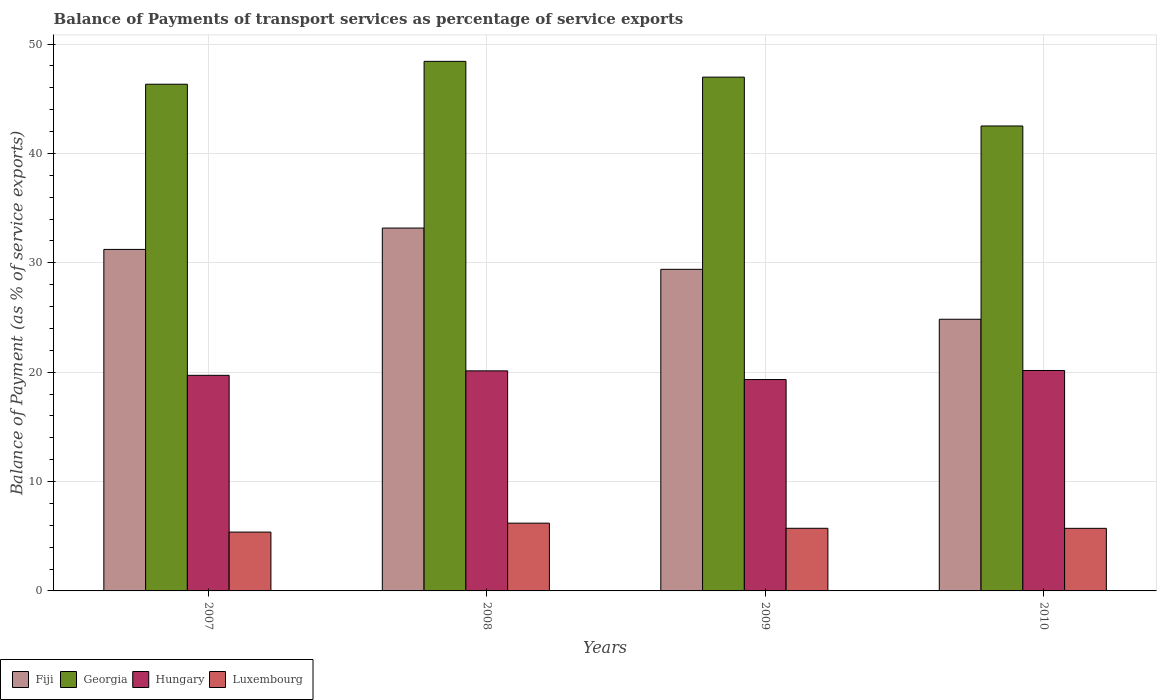Are the number of bars per tick equal to the number of legend labels?
Provide a succinct answer. Yes. Are the number of bars on each tick of the X-axis equal?
Ensure brevity in your answer.  Yes. How many bars are there on the 1st tick from the left?
Provide a succinct answer. 4. How many bars are there on the 4th tick from the right?
Give a very brief answer. 4. In how many cases, is the number of bars for a given year not equal to the number of legend labels?
Give a very brief answer. 0. What is the balance of payments of transport services in Hungary in 2009?
Your response must be concise. 19.33. Across all years, what is the maximum balance of payments of transport services in Luxembourg?
Provide a succinct answer. 6.2. Across all years, what is the minimum balance of payments of transport services in Hungary?
Ensure brevity in your answer.  19.33. What is the total balance of payments of transport services in Georgia in the graph?
Your answer should be compact. 184.22. What is the difference between the balance of payments of transport services in Luxembourg in 2007 and that in 2010?
Ensure brevity in your answer.  -0.34. What is the difference between the balance of payments of transport services in Fiji in 2008 and the balance of payments of transport services in Hungary in 2009?
Provide a succinct answer. 13.85. What is the average balance of payments of transport services in Fiji per year?
Provide a short and direct response. 29.66. In the year 2010, what is the difference between the balance of payments of transport services in Hungary and balance of payments of transport services in Luxembourg?
Make the answer very short. 14.43. What is the ratio of the balance of payments of transport services in Fiji in 2008 to that in 2010?
Offer a terse response. 1.34. What is the difference between the highest and the second highest balance of payments of transport services in Fiji?
Your answer should be very brief. 1.95. What is the difference between the highest and the lowest balance of payments of transport services in Hungary?
Offer a very short reply. 0.83. Is it the case that in every year, the sum of the balance of payments of transport services in Luxembourg and balance of payments of transport services in Fiji is greater than the sum of balance of payments of transport services in Georgia and balance of payments of transport services in Hungary?
Your answer should be compact. Yes. What does the 4th bar from the left in 2008 represents?
Give a very brief answer. Luxembourg. What does the 3rd bar from the right in 2010 represents?
Offer a very short reply. Georgia. Is it the case that in every year, the sum of the balance of payments of transport services in Fiji and balance of payments of transport services in Luxembourg is greater than the balance of payments of transport services in Georgia?
Keep it short and to the point. No. How many bars are there?
Your answer should be compact. 16. What is the difference between two consecutive major ticks on the Y-axis?
Your response must be concise. 10. Are the values on the major ticks of Y-axis written in scientific E-notation?
Make the answer very short. No. Does the graph contain any zero values?
Ensure brevity in your answer.  No. Does the graph contain grids?
Offer a very short reply. Yes. What is the title of the graph?
Give a very brief answer. Balance of Payments of transport services as percentage of service exports. What is the label or title of the X-axis?
Provide a succinct answer. Years. What is the label or title of the Y-axis?
Provide a short and direct response. Balance of Payment (as % of service exports). What is the Balance of Payment (as % of service exports) of Fiji in 2007?
Your answer should be very brief. 31.22. What is the Balance of Payment (as % of service exports) in Georgia in 2007?
Your response must be concise. 46.33. What is the Balance of Payment (as % of service exports) in Hungary in 2007?
Your response must be concise. 19.71. What is the Balance of Payment (as % of service exports) in Luxembourg in 2007?
Your response must be concise. 5.38. What is the Balance of Payment (as % of service exports) of Fiji in 2008?
Your answer should be compact. 33.18. What is the Balance of Payment (as % of service exports) in Georgia in 2008?
Your answer should be compact. 48.42. What is the Balance of Payment (as % of service exports) in Hungary in 2008?
Provide a short and direct response. 20.12. What is the Balance of Payment (as % of service exports) in Luxembourg in 2008?
Your answer should be very brief. 6.2. What is the Balance of Payment (as % of service exports) of Fiji in 2009?
Keep it short and to the point. 29.4. What is the Balance of Payment (as % of service exports) of Georgia in 2009?
Ensure brevity in your answer.  46.97. What is the Balance of Payment (as % of service exports) in Hungary in 2009?
Your answer should be very brief. 19.33. What is the Balance of Payment (as % of service exports) in Luxembourg in 2009?
Provide a short and direct response. 5.73. What is the Balance of Payment (as % of service exports) of Fiji in 2010?
Offer a terse response. 24.84. What is the Balance of Payment (as % of service exports) in Georgia in 2010?
Your answer should be compact. 42.51. What is the Balance of Payment (as % of service exports) of Hungary in 2010?
Make the answer very short. 20.15. What is the Balance of Payment (as % of service exports) of Luxembourg in 2010?
Provide a succinct answer. 5.72. Across all years, what is the maximum Balance of Payment (as % of service exports) of Fiji?
Offer a terse response. 33.18. Across all years, what is the maximum Balance of Payment (as % of service exports) in Georgia?
Provide a short and direct response. 48.42. Across all years, what is the maximum Balance of Payment (as % of service exports) of Hungary?
Offer a very short reply. 20.15. Across all years, what is the maximum Balance of Payment (as % of service exports) of Luxembourg?
Keep it short and to the point. 6.2. Across all years, what is the minimum Balance of Payment (as % of service exports) in Fiji?
Offer a terse response. 24.84. Across all years, what is the minimum Balance of Payment (as % of service exports) of Georgia?
Keep it short and to the point. 42.51. Across all years, what is the minimum Balance of Payment (as % of service exports) of Hungary?
Offer a very short reply. 19.33. Across all years, what is the minimum Balance of Payment (as % of service exports) of Luxembourg?
Provide a succinct answer. 5.38. What is the total Balance of Payment (as % of service exports) in Fiji in the graph?
Offer a terse response. 118.64. What is the total Balance of Payment (as % of service exports) in Georgia in the graph?
Keep it short and to the point. 184.22. What is the total Balance of Payment (as % of service exports) in Hungary in the graph?
Give a very brief answer. 79.31. What is the total Balance of Payment (as % of service exports) of Luxembourg in the graph?
Make the answer very short. 23.02. What is the difference between the Balance of Payment (as % of service exports) in Fiji in 2007 and that in 2008?
Ensure brevity in your answer.  -1.95. What is the difference between the Balance of Payment (as % of service exports) in Georgia in 2007 and that in 2008?
Provide a short and direct response. -2.09. What is the difference between the Balance of Payment (as % of service exports) of Hungary in 2007 and that in 2008?
Offer a terse response. -0.41. What is the difference between the Balance of Payment (as % of service exports) of Luxembourg in 2007 and that in 2008?
Your answer should be compact. -0.82. What is the difference between the Balance of Payment (as % of service exports) of Fiji in 2007 and that in 2009?
Keep it short and to the point. 1.82. What is the difference between the Balance of Payment (as % of service exports) of Georgia in 2007 and that in 2009?
Ensure brevity in your answer.  -0.65. What is the difference between the Balance of Payment (as % of service exports) in Hungary in 2007 and that in 2009?
Your response must be concise. 0.39. What is the difference between the Balance of Payment (as % of service exports) in Luxembourg in 2007 and that in 2009?
Ensure brevity in your answer.  -0.35. What is the difference between the Balance of Payment (as % of service exports) of Fiji in 2007 and that in 2010?
Your answer should be compact. 6.39. What is the difference between the Balance of Payment (as % of service exports) in Georgia in 2007 and that in 2010?
Offer a very short reply. 3.82. What is the difference between the Balance of Payment (as % of service exports) in Hungary in 2007 and that in 2010?
Keep it short and to the point. -0.44. What is the difference between the Balance of Payment (as % of service exports) in Luxembourg in 2007 and that in 2010?
Your response must be concise. -0.34. What is the difference between the Balance of Payment (as % of service exports) of Fiji in 2008 and that in 2009?
Provide a short and direct response. 3.77. What is the difference between the Balance of Payment (as % of service exports) of Georgia in 2008 and that in 2009?
Keep it short and to the point. 1.44. What is the difference between the Balance of Payment (as % of service exports) of Hungary in 2008 and that in 2009?
Ensure brevity in your answer.  0.79. What is the difference between the Balance of Payment (as % of service exports) in Luxembourg in 2008 and that in 2009?
Give a very brief answer. 0.47. What is the difference between the Balance of Payment (as % of service exports) in Fiji in 2008 and that in 2010?
Keep it short and to the point. 8.34. What is the difference between the Balance of Payment (as % of service exports) of Georgia in 2008 and that in 2010?
Provide a succinct answer. 5.91. What is the difference between the Balance of Payment (as % of service exports) in Hungary in 2008 and that in 2010?
Offer a very short reply. -0.03. What is the difference between the Balance of Payment (as % of service exports) in Luxembourg in 2008 and that in 2010?
Offer a very short reply. 0.47. What is the difference between the Balance of Payment (as % of service exports) in Fiji in 2009 and that in 2010?
Give a very brief answer. 4.57. What is the difference between the Balance of Payment (as % of service exports) of Georgia in 2009 and that in 2010?
Your answer should be very brief. 4.47. What is the difference between the Balance of Payment (as % of service exports) in Hungary in 2009 and that in 2010?
Your answer should be very brief. -0.83. What is the difference between the Balance of Payment (as % of service exports) in Luxembourg in 2009 and that in 2010?
Your response must be concise. 0. What is the difference between the Balance of Payment (as % of service exports) of Fiji in 2007 and the Balance of Payment (as % of service exports) of Georgia in 2008?
Provide a succinct answer. -17.19. What is the difference between the Balance of Payment (as % of service exports) in Fiji in 2007 and the Balance of Payment (as % of service exports) in Hungary in 2008?
Your answer should be compact. 11.1. What is the difference between the Balance of Payment (as % of service exports) in Fiji in 2007 and the Balance of Payment (as % of service exports) in Luxembourg in 2008?
Ensure brevity in your answer.  25.03. What is the difference between the Balance of Payment (as % of service exports) in Georgia in 2007 and the Balance of Payment (as % of service exports) in Hungary in 2008?
Offer a very short reply. 26.21. What is the difference between the Balance of Payment (as % of service exports) of Georgia in 2007 and the Balance of Payment (as % of service exports) of Luxembourg in 2008?
Your response must be concise. 40.13. What is the difference between the Balance of Payment (as % of service exports) in Hungary in 2007 and the Balance of Payment (as % of service exports) in Luxembourg in 2008?
Provide a short and direct response. 13.52. What is the difference between the Balance of Payment (as % of service exports) of Fiji in 2007 and the Balance of Payment (as % of service exports) of Georgia in 2009?
Your answer should be compact. -15.75. What is the difference between the Balance of Payment (as % of service exports) in Fiji in 2007 and the Balance of Payment (as % of service exports) in Hungary in 2009?
Your answer should be compact. 11.9. What is the difference between the Balance of Payment (as % of service exports) in Fiji in 2007 and the Balance of Payment (as % of service exports) in Luxembourg in 2009?
Your response must be concise. 25.5. What is the difference between the Balance of Payment (as % of service exports) of Georgia in 2007 and the Balance of Payment (as % of service exports) of Hungary in 2009?
Your answer should be compact. 27. What is the difference between the Balance of Payment (as % of service exports) of Georgia in 2007 and the Balance of Payment (as % of service exports) of Luxembourg in 2009?
Keep it short and to the point. 40.6. What is the difference between the Balance of Payment (as % of service exports) of Hungary in 2007 and the Balance of Payment (as % of service exports) of Luxembourg in 2009?
Your answer should be very brief. 13.99. What is the difference between the Balance of Payment (as % of service exports) of Fiji in 2007 and the Balance of Payment (as % of service exports) of Georgia in 2010?
Offer a terse response. -11.29. What is the difference between the Balance of Payment (as % of service exports) in Fiji in 2007 and the Balance of Payment (as % of service exports) in Hungary in 2010?
Offer a terse response. 11.07. What is the difference between the Balance of Payment (as % of service exports) of Fiji in 2007 and the Balance of Payment (as % of service exports) of Luxembourg in 2010?
Provide a succinct answer. 25.5. What is the difference between the Balance of Payment (as % of service exports) in Georgia in 2007 and the Balance of Payment (as % of service exports) in Hungary in 2010?
Give a very brief answer. 26.17. What is the difference between the Balance of Payment (as % of service exports) in Georgia in 2007 and the Balance of Payment (as % of service exports) in Luxembourg in 2010?
Provide a succinct answer. 40.6. What is the difference between the Balance of Payment (as % of service exports) of Hungary in 2007 and the Balance of Payment (as % of service exports) of Luxembourg in 2010?
Give a very brief answer. 13.99. What is the difference between the Balance of Payment (as % of service exports) in Fiji in 2008 and the Balance of Payment (as % of service exports) in Georgia in 2009?
Your answer should be very brief. -13.8. What is the difference between the Balance of Payment (as % of service exports) in Fiji in 2008 and the Balance of Payment (as % of service exports) in Hungary in 2009?
Offer a terse response. 13.85. What is the difference between the Balance of Payment (as % of service exports) in Fiji in 2008 and the Balance of Payment (as % of service exports) in Luxembourg in 2009?
Give a very brief answer. 27.45. What is the difference between the Balance of Payment (as % of service exports) in Georgia in 2008 and the Balance of Payment (as % of service exports) in Hungary in 2009?
Make the answer very short. 29.09. What is the difference between the Balance of Payment (as % of service exports) of Georgia in 2008 and the Balance of Payment (as % of service exports) of Luxembourg in 2009?
Your response must be concise. 42.69. What is the difference between the Balance of Payment (as % of service exports) in Hungary in 2008 and the Balance of Payment (as % of service exports) in Luxembourg in 2009?
Give a very brief answer. 14.39. What is the difference between the Balance of Payment (as % of service exports) of Fiji in 2008 and the Balance of Payment (as % of service exports) of Georgia in 2010?
Offer a terse response. -9.33. What is the difference between the Balance of Payment (as % of service exports) in Fiji in 2008 and the Balance of Payment (as % of service exports) in Hungary in 2010?
Your response must be concise. 13.02. What is the difference between the Balance of Payment (as % of service exports) of Fiji in 2008 and the Balance of Payment (as % of service exports) of Luxembourg in 2010?
Provide a short and direct response. 27.45. What is the difference between the Balance of Payment (as % of service exports) of Georgia in 2008 and the Balance of Payment (as % of service exports) of Hungary in 2010?
Offer a very short reply. 28.26. What is the difference between the Balance of Payment (as % of service exports) in Georgia in 2008 and the Balance of Payment (as % of service exports) in Luxembourg in 2010?
Your answer should be very brief. 42.7. What is the difference between the Balance of Payment (as % of service exports) in Hungary in 2008 and the Balance of Payment (as % of service exports) in Luxembourg in 2010?
Keep it short and to the point. 14.4. What is the difference between the Balance of Payment (as % of service exports) of Fiji in 2009 and the Balance of Payment (as % of service exports) of Georgia in 2010?
Offer a very short reply. -13.11. What is the difference between the Balance of Payment (as % of service exports) of Fiji in 2009 and the Balance of Payment (as % of service exports) of Hungary in 2010?
Provide a succinct answer. 9.25. What is the difference between the Balance of Payment (as % of service exports) of Fiji in 2009 and the Balance of Payment (as % of service exports) of Luxembourg in 2010?
Your answer should be compact. 23.68. What is the difference between the Balance of Payment (as % of service exports) in Georgia in 2009 and the Balance of Payment (as % of service exports) in Hungary in 2010?
Your answer should be very brief. 26.82. What is the difference between the Balance of Payment (as % of service exports) in Georgia in 2009 and the Balance of Payment (as % of service exports) in Luxembourg in 2010?
Make the answer very short. 41.25. What is the difference between the Balance of Payment (as % of service exports) in Hungary in 2009 and the Balance of Payment (as % of service exports) in Luxembourg in 2010?
Provide a short and direct response. 13.6. What is the average Balance of Payment (as % of service exports) of Fiji per year?
Keep it short and to the point. 29.66. What is the average Balance of Payment (as % of service exports) in Georgia per year?
Your response must be concise. 46.06. What is the average Balance of Payment (as % of service exports) of Hungary per year?
Keep it short and to the point. 19.83. What is the average Balance of Payment (as % of service exports) of Luxembourg per year?
Provide a short and direct response. 5.76. In the year 2007, what is the difference between the Balance of Payment (as % of service exports) of Fiji and Balance of Payment (as % of service exports) of Georgia?
Your response must be concise. -15.1. In the year 2007, what is the difference between the Balance of Payment (as % of service exports) of Fiji and Balance of Payment (as % of service exports) of Hungary?
Your answer should be compact. 11.51. In the year 2007, what is the difference between the Balance of Payment (as % of service exports) in Fiji and Balance of Payment (as % of service exports) in Luxembourg?
Your answer should be very brief. 25.84. In the year 2007, what is the difference between the Balance of Payment (as % of service exports) of Georgia and Balance of Payment (as % of service exports) of Hungary?
Your answer should be very brief. 26.61. In the year 2007, what is the difference between the Balance of Payment (as % of service exports) in Georgia and Balance of Payment (as % of service exports) in Luxembourg?
Offer a terse response. 40.95. In the year 2007, what is the difference between the Balance of Payment (as % of service exports) of Hungary and Balance of Payment (as % of service exports) of Luxembourg?
Give a very brief answer. 14.33. In the year 2008, what is the difference between the Balance of Payment (as % of service exports) in Fiji and Balance of Payment (as % of service exports) in Georgia?
Make the answer very short. -15.24. In the year 2008, what is the difference between the Balance of Payment (as % of service exports) in Fiji and Balance of Payment (as % of service exports) in Hungary?
Make the answer very short. 13.06. In the year 2008, what is the difference between the Balance of Payment (as % of service exports) of Fiji and Balance of Payment (as % of service exports) of Luxembourg?
Provide a short and direct response. 26.98. In the year 2008, what is the difference between the Balance of Payment (as % of service exports) of Georgia and Balance of Payment (as % of service exports) of Hungary?
Make the answer very short. 28.3. In the year 2008, what is the difference between the Balance of Payment (as % of service exports) in Georgia and Balance of Payment (as % of service exports) in Luxembourg?
Your answer should be compact. 42.22. In the year 2008, what is the difference between the Balance of Payment (as % of service exports) in Hungary and Balance of Payment (as % of service exports) in Luxembourg?
Provide a succinct answer. 13.92. In the year 2009, what is the difference between the Balance of Payment (as % of service exports) of Fiji and Balance of Payment (as % of service exports) of Georgia?
Offer a terse response. -17.57. In the year 2009, what is the difference between the Balance of Payment (as % of service exports) of Fiji and Balance of Payment (as % of service exports) of Hungary?
Ensure brevity in your answer.  10.08. In the year 2009, what is the difference between the Balance of Payment (as % of service exports) of Fiji and Balance of Payment (as % of service exports) of Luxembourg?
Keep it short and to the point. 23.68. In the year 2009, what is the difference between the Balance of Payment (as % of service exports) of Georgia and Balance of Payment (as % of service exports) of Hungary?
Offer a terse response. 27.65. In the year 2009, what is the difference between the Balance of Payment (as % of service exports) of Georgia and Balance of Payment (as % of service exports) of Luxembourg?
Keep it short and to the point. 41.25. In the year 2009, what is the difference between the Balance of Payment (as % of service exports) in Hungary and Balance of Payment (as % of service exports) in Luxembourg?
Provide a succinct answer. 13.6. In the year 2010, what is the difference between the Balance of Payment (as % of service exports) of Fiji and Balance of Payment (as % of service exports) of Georgia?
Your response must be concise. -17.67. In the year 2010, what is the difference between the Balance of Payment (as % of service exports) in Fiji and Balance of Payment (as % of service exports) in Hungary?
Your answer should be compact. 4.68. In the year 2010, what is the difference between the Balance of Payment (as % of service exports) in Fiji and Balance of Payment (as % of service exports) in Luxembourg?
Your answer should be compact. 19.11. In the year 2010, what is the difference between the Balance of Payment (as % of service exports) of Georgia and Balance of Payment (as % of service exports) of Hungary?
Give a very brief answer. 22.35. In the year 2010, what is the difference between the Balance of Payment (as % of service exports) in Georgia and Balance of Payment (as % of service exports) in Luxembourg?
Provide a succinct answer. 36.79. In the year 2010, what is the difference between the Balance of Payment (as % of service exports) of Hungary and Balance of Payment (as % of service exports) of Luxembourg?
Give a very brief answer. 14.43. What is the ratio of the Balance of Payment (as % of service exports) of Fiji in 2007 to that in 2008?
Provide a short and direct response. 0.94. What is the ratio of the Balance of Payment (as % of service exports) in Georgia in 2007 to that in 2008?
Provide a succinct answer. 0.96. What is the ratio of the Balance of Payment (as % of service exports) of Hungary in 2007 to that in 2008?
Offer a terse response. 0.98. What is the ratio of the Balance of Payment (as % of service exports) of Luxembourg in 2007 to that in 2008?
Provide a short and direct response. 0.87. What is the ratio of the Balance of Payment (as % of service exports) of Fiji in 2007 to that in 2009?
Ensure brevity in your answer.  1.06. What is the ratio of the Balance of Payment (as % of service exports) of Georgia in 2007 to that in 2009?
Ensure brevity in your answer.  0.99. What is the ratio of the Balance of Payment (as % of service exports) in Luxembourg in 2007 to that in 2009?
Your answer should be very brief. 0.94. What is the ratio of the Balance of Payment (as % of service exports) of Fiji in 2007 to that in 2010?
Offer a very short reply. 1.26. What is the ratio of the Balance of Payment (as % of service exports) in Georgia in 2007 to that in 2010?
Your answer should be compact. 1.09. What is the ratio of the Balance of Payment (as % of service exports) in Hungary in 2007 to that in 2010?
Your response must be concise. 0.98. What is the ratio of the Balance of Payment (as % of service exports) of Luxembourg in 2007 to that in 2010?
Offer a very short reply. 0.94. What is the ratio of the Balance of Payment (as % of service exports) in Fiji in 2008 to that in 2009?
Your answer should be very brief. 1.13. What is the ratio of the Balance of Payment (as % of service exports) of Georgia in 2008 to that in 2009?
Give a very brief answer. 1.03. What is the ratio of the Balance of Payment (as % of service exports) of Hungary in 2008 to that in 2009?
Provide a short and direct response. 1.04. What is the ratio of the Balance of Payment (as % of service exports) in Luxembourg in 2008 to that in 2009?
Provide a succinct answer. 1.08. What is the ratio of the Balance of Payment (as % of service exports) of Fiji in 2008 to that in 2010?
Your answer should be very brief. 1.34. What is the ratio of the Balance of Payment (as % of service exports) of Georgia in 2008 to that in 2010?
Your response must be concise. 1.14. What is the ratio of the Balance of Payment (as % of service exports) of Luxembourg in 2008 to that in 2010?
Offer a terse response. 1.08. What is the ratio of the Balance of Payment (as % of service exports) in Fiji in 2009 to that in 2010?
Your answer should be very brief. 1.18. What is the ratio of the Balance of Payment (as % of service exports) in Georgia in 2009 to that in 2010?
Offer a very short reply. 1.1. What is the ratio of the Balance of Payment (as % of service exports) of Hungary in 2009 to that in 2010?
Ensure brevity in your answer.  0.96. What is the difference between the highest and the second highest Balance of Payment (as % of service exports) in Fiji?
Make the answer very short. 1.95. What is the difference between the highest and the second highest Balance of Payment (as % of service exports) of Georgia?
Make the answer very short. 1.44. What is the difference between the highest and the second highest Balance of Payment (as % of service exports) of Hungary?
Give a very brief answer. 0.03. What is the difference between the highest and the second highest Balance of Payment (as % of service exports) in Luxembourg?
Ensure brevity in your answer.  0.47. What is the difference between the highest and the lowest Balance of Payment (as % of service exports) in Fiji?
Your answer should be very brief. 8.34. What is the difference between the highest and the lowest Balance of Payment (as % of service exports) in Georgia?
Your answer should be very brief. 5.91. What is the difference between the highest and the lowest Balance of Payment (as % of service exports) of Hungary?
Make the answer very short. 0.83. What is the difference between the highest and the lowest Balance of Payment (as % of service exports) in Luxembourg?
Give a very brief answer. 0.82. 